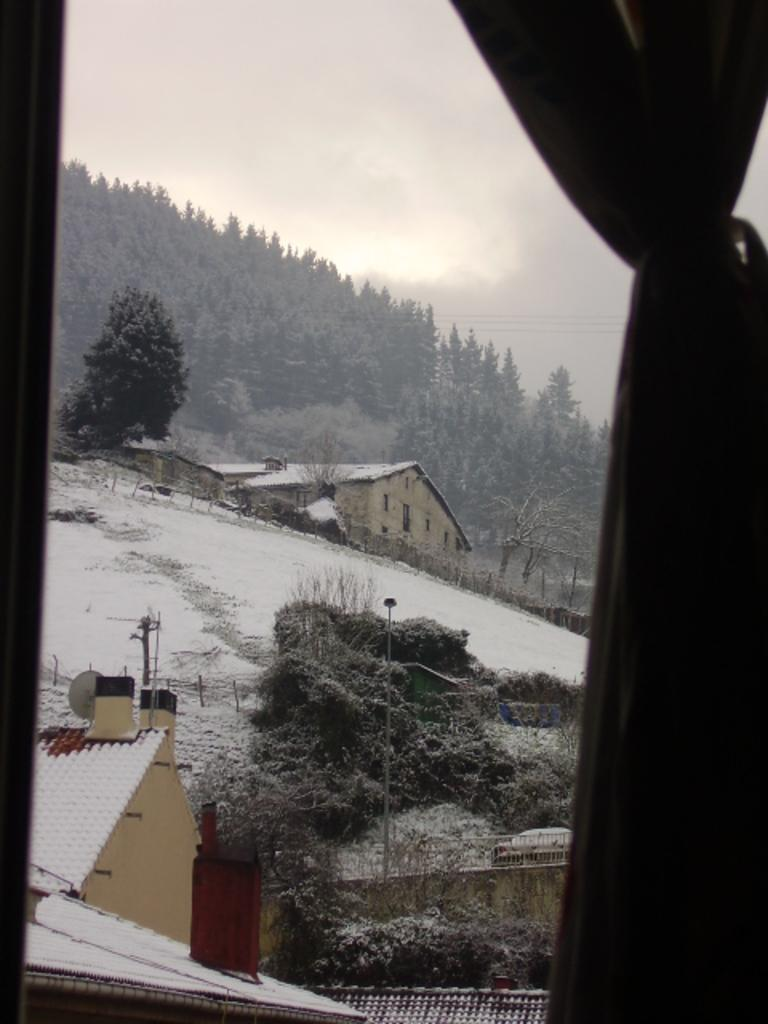What is located in the front of the image? There is a curtain in the front of the image. What can be seen in the background of the image? There are trees and houses in the background of the image. What is the weather like in the image? The sky is cloudy, and there is snow on the ground in the image. Can you see any bushes in the image? There is no mention of bushes in the provided facts, so we cannot determine if they are present in the image. Is there a bottle visible in the image? There is no mention of a bottle in the provided facts, so we cannot determine if it is present in the image. 